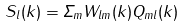Convert formula to latex. <formula><loc_0><loc_0><loc_500><loc_500>S _ { l } ( { k } ) = \Sigma _ { m } W _ { l m } ( { k } ) Q _ { m l } ( { k } )</formula> 